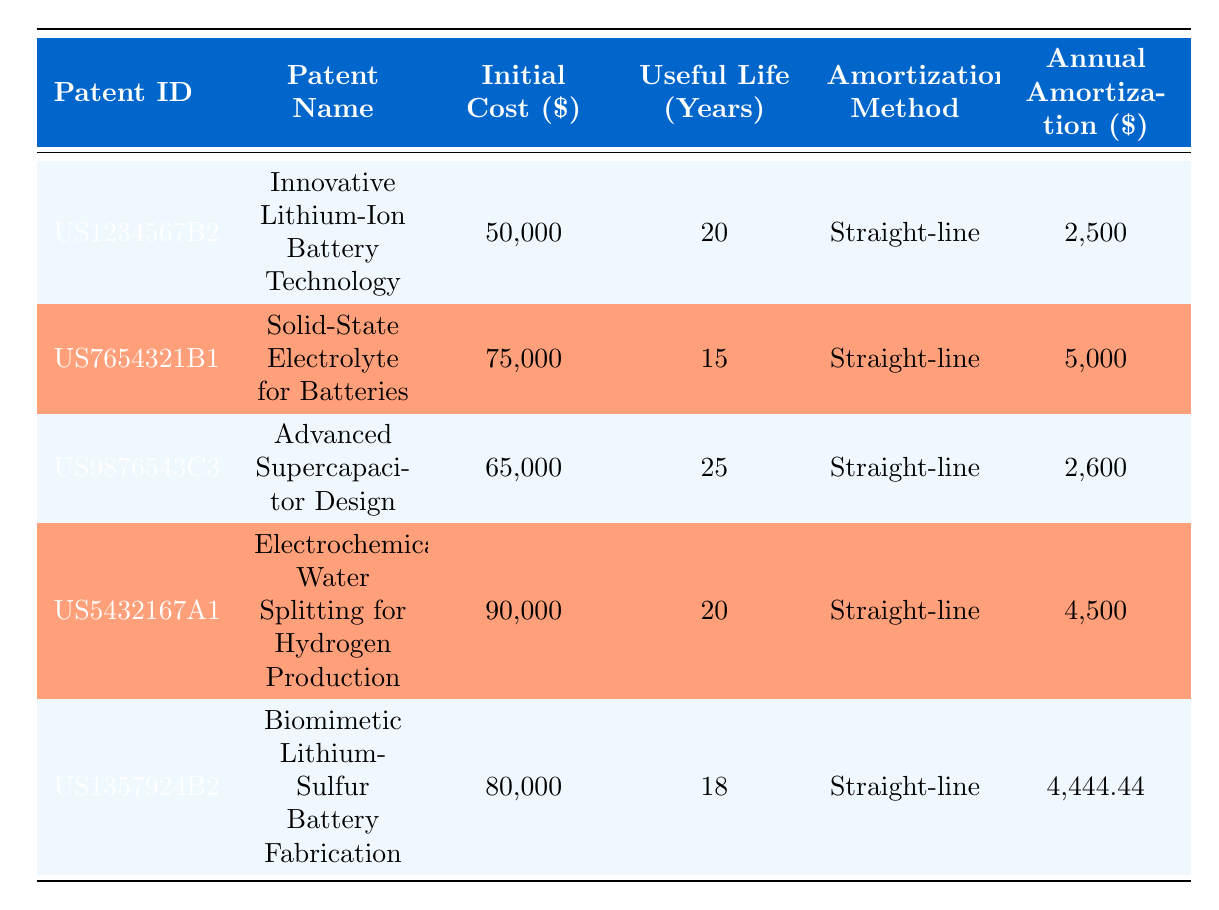What is the filing date of the patent "Biomimetic Lithium-Sulfur Battery Fabrication"? The table displays the filing date for each patent under the "filing_date" column. The specific patent "Biomimetic Lithium-Sulfur Battery Fabrication" corresponds to the patent ID "US1357924B2", which has a filing date of "2021-12-01".
Answer: 2021-12-01 How much is the annual amortization for the patent "Solid-State Electrolyte for Batteries"? Looking at the row corresponding to the patent "Solid-State Electrolyte for Batteries" with the patent ID "US7654321B1", the "Annual Amortization" column indicates the amount is 5000.
Answer: 5000 Which patent has the longest useful life? The "Useful Life (Years)" column shows the years for each patent. By comparing the values, the longest useful life is 25 years, associated with the patent "Advanced Supercapacitor Design" (ID: US9876543C3).
Answer: Advanced Supercapacitor Design What is the total initial cost of all patents listed in the table? The initial costs from the "Initial Cost (\$)" column are 50000, 75000, 65000, 90000, and 80000. Adding these amounts: 50000 + 75000 + 65000 + 90000 + 80000 = 360000.
Answer: 360000 Is the annual amortization for "Electrochemical Water Splitting for Hydrogen Production" greater than 4000? The annual amortization for the mentioned patent (ID: US5432167A1) is 4500 according to the table, which is clearly greater than 4000.
Answer: Yes If we average the annual amortization amounts of all patents, what is the result? The annual amortization values are 2500, 5000, 2600, 4500, and 4444.44. First, sum these values: 2500 + 5000 + 2600 + 4500 + 4444.44 = 19044.44. Then divide by the number of patents (5): 19044.44 / 5 = 3808.888. Rounding to two decimal places gives 3808.89.
Answer: 3808.89 Which patent has the highest initial cost? By examining the "Initial Cost (\$)" column, the highest amount is 90000, which corresponds to the patent "Electrochemical Water Splitting for Hydrogen Production".
Answer: Electrochemical Water Splitting for Hydrogen Production Are all the patents using the straight-line amortization method? The "Amortization Method" column indicates that all listed patents use the "Straight-line" method, confirming that this statement is true.
Answer: Yes 